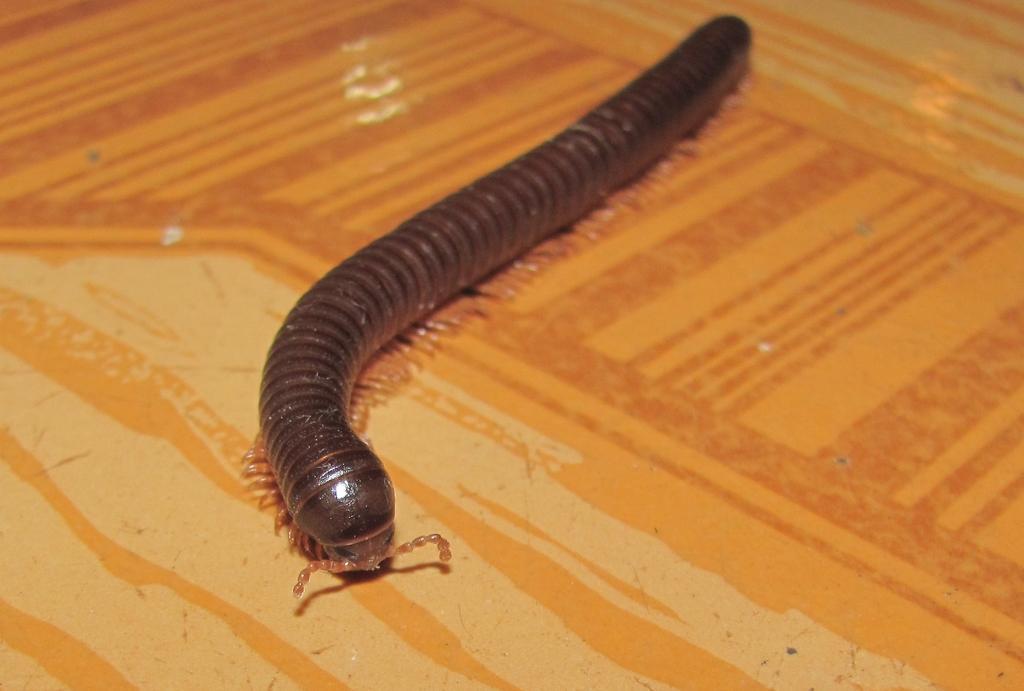Could you give a brief overview of what you see in this image? In this image I can see the surface which is orange, brown and cream in color and on the surface I can see an insect which is black and brown in color. 